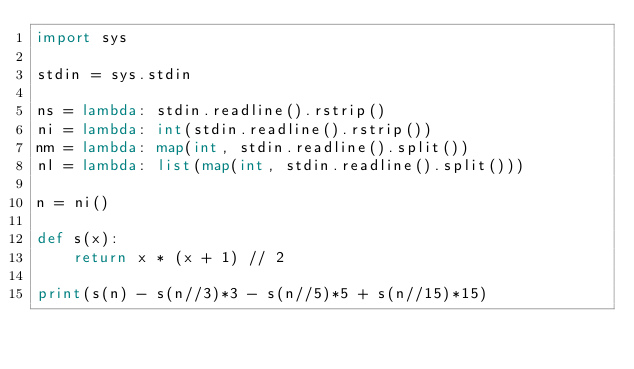<code> <loc_0><loc_0><loc_500><loc_500><_Python_>import sys

stdin = sys.stdin

ns = lambda: stdin.readline().rstrip()
ni = lambda: int(stdin.readline().rstrip())
nm = lambda: map(int, stdin.readline().split())
nl = lambda: list(map(int, stdin.readline().split()))

n = ni()

def s(x):
    return x * (x + 1) // 2

print(s(n) - s(n//3)*3 - s(n//5)*5 + s(n//15)*15)
</code> 